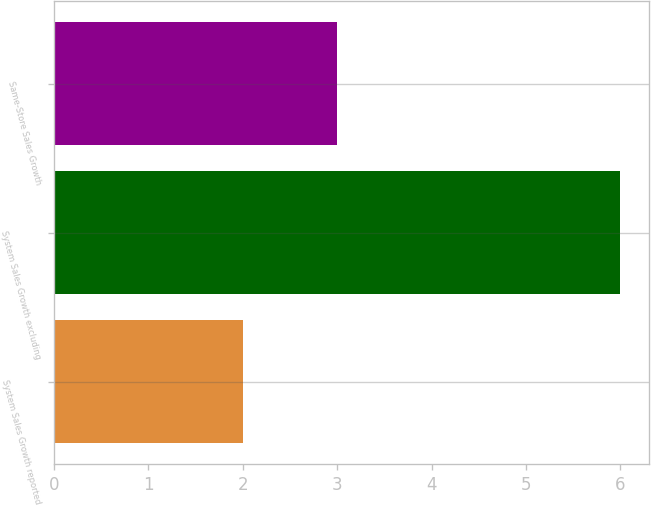<chart> <loc_0><loc_0><loc_500><loc_500><bar_chart><fcel>System Sales Growth reported<fcel>System Sales Growth excluding<fcel>Same-Store Sales Growth<nl><fcel>2<fcel>6<fcel>3<nl></chart> 